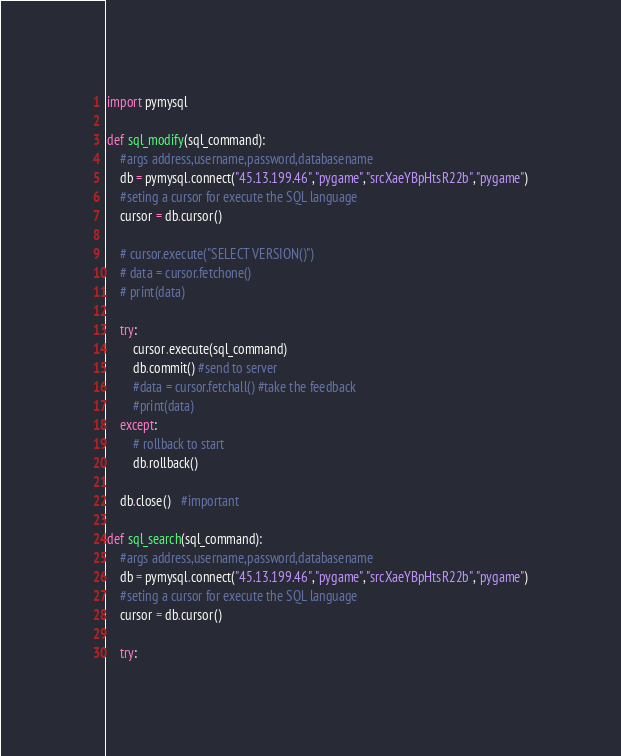Convert code to text. <code><loc_0><loc_0><loc_500><loc_500><_Python_>import pymysql

def sql_modify(sql_command):
    #args address,username,password,databasename
    db = pymysql.connect("45.13.199.46","pygame","srcXaeYBpHtsR22b","pygame")
    #seting a cursor for execute the SQL language
    cursor = db.cursor()

    # cursor.execute("SELECT VERSION()")
    # data = cursor.fetchone()
    # print(data)

    try:
        cursor.execute(sql_command)
        db.commit() #send to server
        #data = cursor.fetchall() #take the feedback
        #print(data)
    except:
        # rollback to start
        db.rollback()

    db.close()   #important

def sql_search(sql_command):
    #args address,username,password,databasename
    db = pymysql.connect("45.13.199.46","pygame","srcXaeYBpHtsR22b","pygame")
    #seting a cursor for execute the SQL language
    cursor = db.cursor()

    try:</code> 